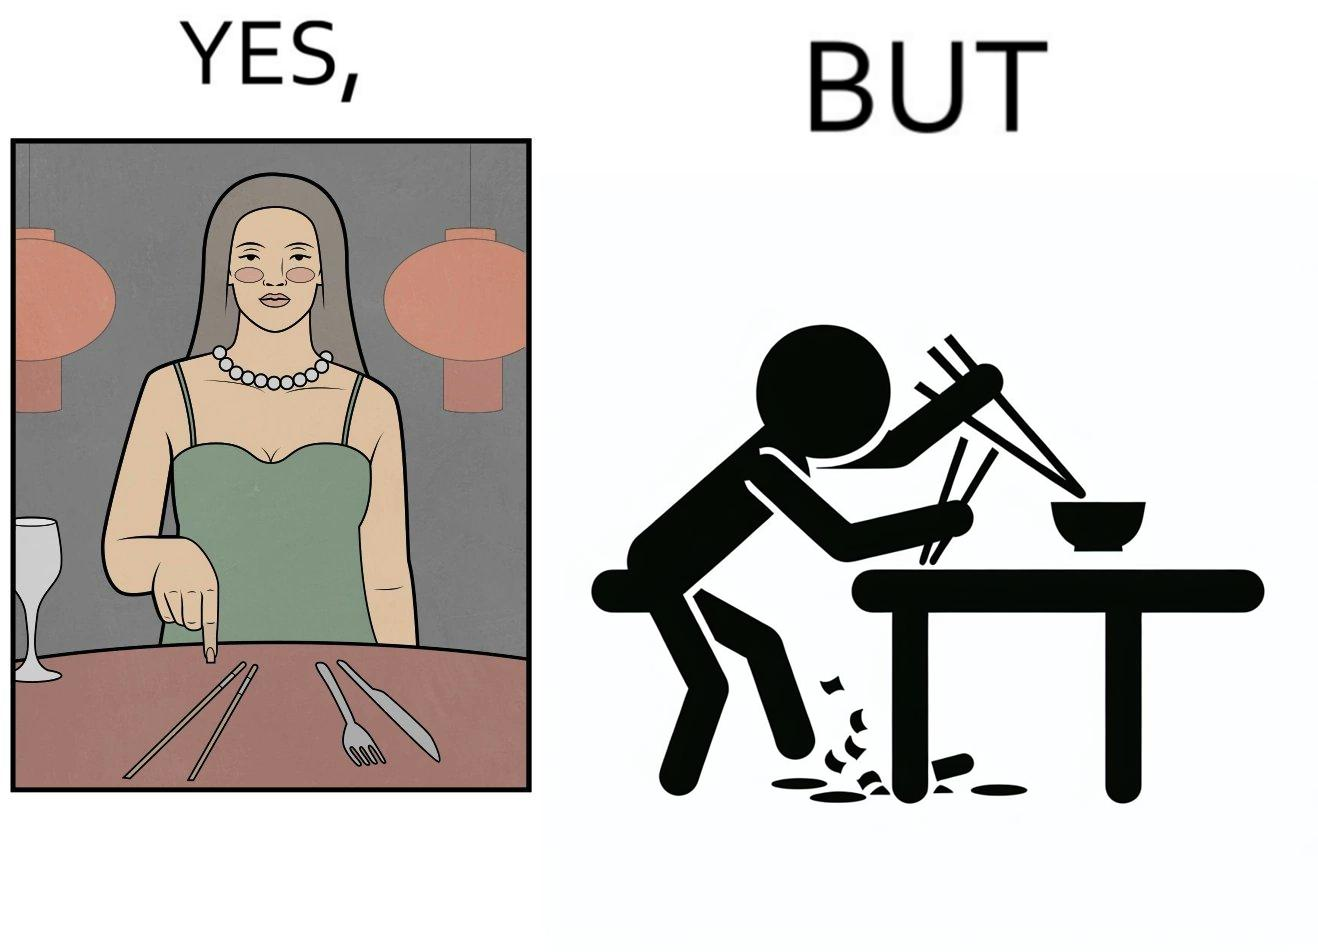Explain why this image is satirical. The image is satirical because even thought the woman is not able to eat food with chopstick properly, she chooses it over fork and knife to look sophisticaed. 